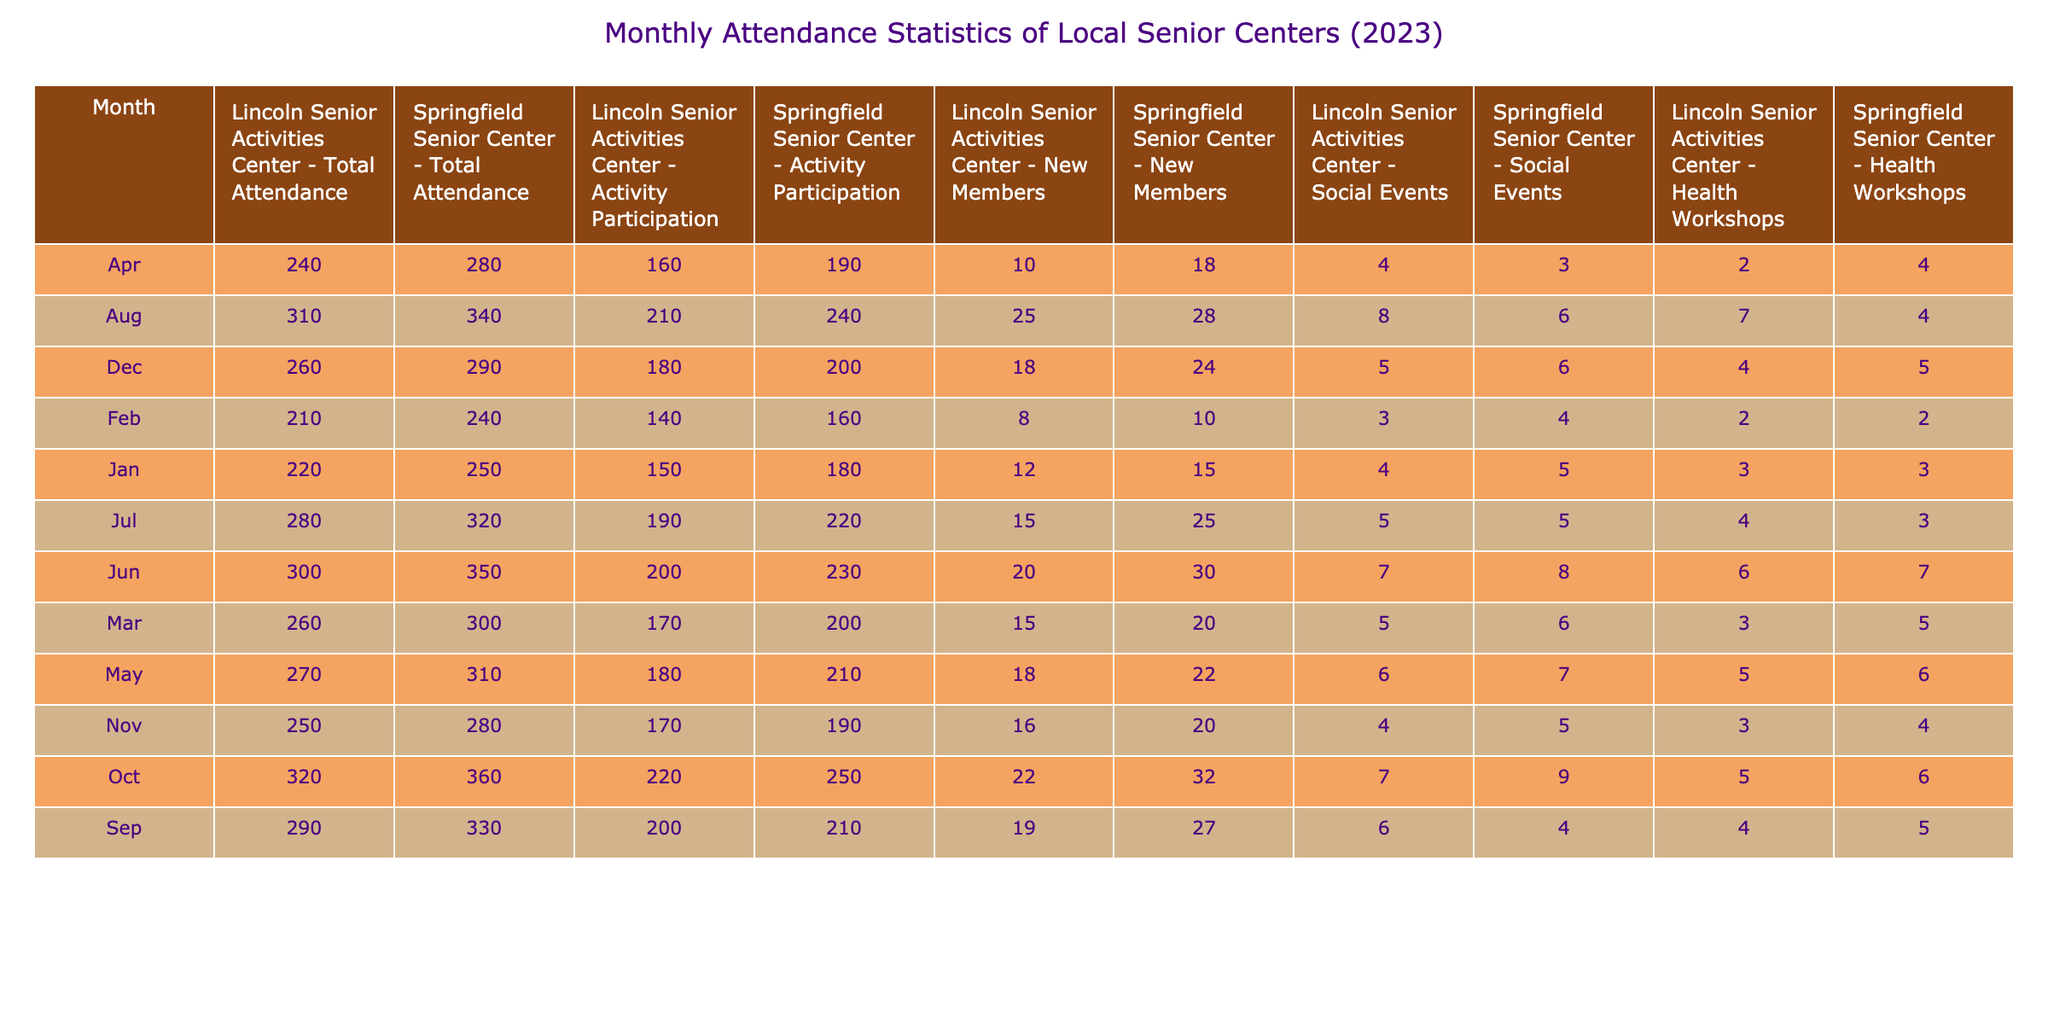What was the total attendance at the Springfield Senior Center in March? The table shows the total attendance for the Springfield Senior Center in March. Looking at the relevant column for March, the value is 300.
Answer: 300 Which month had the highest activity participation at the Lincoln Senior Activities Center? To find the month with the highest activity participation at the Lincoln Senior Activities Center, I compare the values under the "Activity Participation - Lincoln Senior Activities Center" column. June has the highest value at 200.
Answer: June What was the total attendance at the Lincoln Senior Activities Center for the entire year? The total attendance for the Lincoln Senior Activities Center can be calculated by adding the values from each month: 220 + 210 + 260 + 240 + 270 + 300 + 280 + 310 + 290 + 320 + 250 + 260 = 3,120.
Answer: 3120 Did the Springfield Senior Center have more social events than the Lincoln Senior Activities Center in April? In April, the Springfield Senior Center had 3 social events, while the Lincoln Senior Activities Center had 4. Since 3 is less than 4, Springfield had fewer social events than Lincoln.
Answer: No What was the average number of new members across all months for the Springfield Senior Center? To find the average number of new members, sum the values in the "New Members - Springfield Senior Center" column for all months: (15 + 10 + 20 + 18 + 22 + 30 + 25 + 28 + 27 + 32 + 20 + 24) =  300. Divide by 12 (the number of months): 300 / 12 = 25.
Answer: 25 In which month did the Springfield Senior Center see the highest increase in total attendance compared to the previous month? To determine the month with the highest increase in total attendance, I calculate the differences between each month’s attendance and the previous month’s attendance: February to March increased by 60 (300 - 240), March to April decreased by 20, and so on. The highest increase is from February to March.
Answer: March What was the total number of health workshops conducted in the Lincoln Senior Activities Center from July to December? To find the total number of health workshops from July to December, I add the values: 4 (July) + 7 (August) + 4 (September) + 5 (October) + 3 (November) + 4 (December) = 27.
Answer: 27 Which senior center had a higher total attendance in October, and what was the attendance? In October, Springfield Senior Center had 360, whereas Lincoln Senior Activities Center had 320. Springfield's attendance is higher; thus, Springfield had the higher total attendance.
Answer: Springfield Senior Center, 360 Was there a month in 2023 where the total attendance at the Lincoln Senior Activities Center dropped below 250? Checking the table for Lincoln Senior Activities Center, all attendance figures were above 250 in November (250) and December (260), which means it was never below 250.
Answer: No What was the difference in the number of social events between the two senior centers in May? In May, Springfield Senior Center had 7 social events, and Lincoln Senior Activities Center had 6. The difference is 7 - 6 = 1.
Answer: 1 